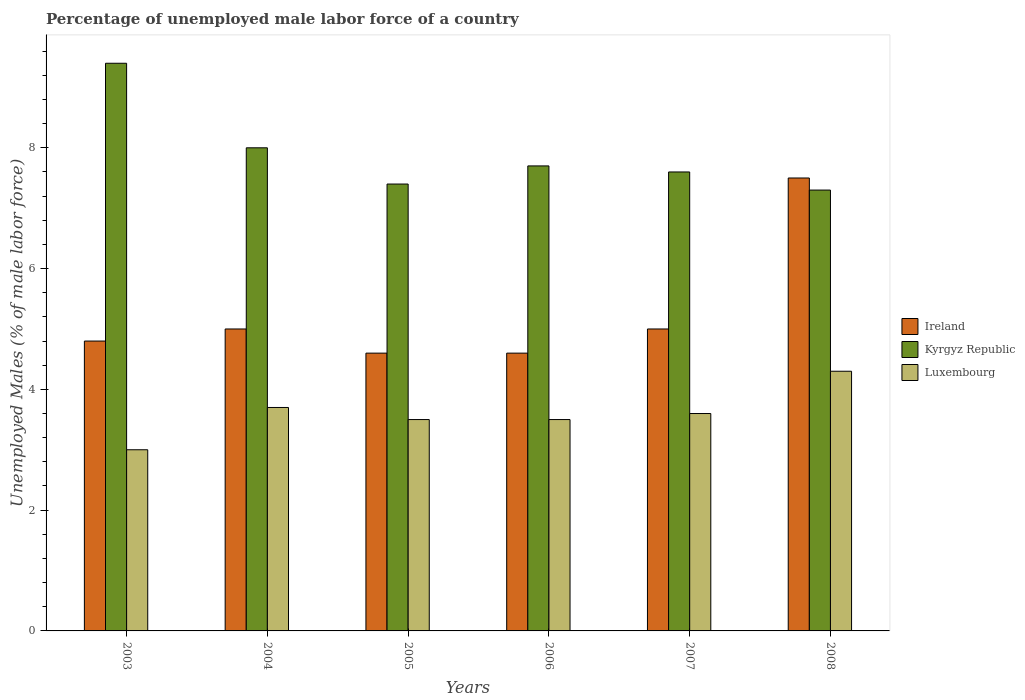How many groups of bars are there?
Your answer should be very brief. 6. In how many cases, is the number of bars for a given year not equal to the number of legend labels?
Make the answer very short. 0. What is the percentage of unemployed male labor force in Luxembourg in 2006?
Your answer should be very brief. 3.5. Across all years, what is the maximum percentage of unemployed male labor force in Kyrgyz Republic?
Your response must be concise. 9.4. Across all years, what is the minimum percentage of unemployed male labor force in Kyrgyz Republic?
Provide a short and direct response. 7.3. In which year was the percentage of unemployed male labor force in Luxembourg minimum?
Your response must be concise. 2003. What is the total percentage of unemployed male labor force in Luxembourg in the graph?
Your answer should be very brief. 21.6. What is the difference between the percentage of unemployed male labor force in Kyrgyz Republic in 2007 and that in 2008?
Offer a terse response. 0.3. What is the difference between the percentage of unemployed male labor force in Kyrgyz Republic in 2007 and the percentage of unemployed male labor force in Luxembourg in 2005?
Offer a terse response. 4.1. What is the average percentage of unemployed male labor force in Kyrgyz Republic per year?
Your answer should be very brief. 7.9. In the year 2005, what is the difference between the percentage of unemployed male labor force in Ireland and percentage of unemployed male labor force in Kyrgyz Republic?
Offer a terse response. -2.8. In how many years, is the percentage of unemployed male labor force in Kyrgyz Republic greater than 8.4 %?
Your response must be concise. 1. What is the ratio of the percentage of unemployed male labor force in Luxembourg in 2007 to that in 2008?
Your answer should be very brief. 0.84. Is the percentage of unemployed male labor force in Ireland in 2004 less than that in 2006?
Offer a very short reply. No. Is the difference between the percentage of unemployed male labor force in Ireland in 2004 and 2007 greater than the difference between the percentage of unemployed male labor force in Kyrgyz Republic in 2004 and 2007?
Your response must be concise. No. What is the difference between the highest and the lowest percentage of unemployed male labor force in Luxembourg?
Your answer should be compact. 1.3. In how many years, is the percentage of unemployed male labor force in Ireland greater than the average percentage of unemployed male labor force in Ireland taken over all years?
Ensure brevity in your answer.  1. What does the 1st bar from the left in 2006 represents?
Make the answer very short. Ireland. What does the 3rd bar from the right in 2006 represents?
Offer a very short reply. Ireland. How many bars are there?
Offer a terse response. 18. Are all the bars in the graph horizontal?
Offer a very short reply. No. What is the difference between two consecutive major ticks on the Y-axis?
Give a very brief answer. 2. Does the graph contain any zero values?
Your answer should be very brief. No. Where does the legend appear in the graph?
Give a very brief answer. Center right. How many legend labels are there?
Your answer should be compact. 3. What is the title of the graph?
Give a very brief answer. Percentage of unemployed male labor force of a country. What is the label or title of the X-axis?
Offer a terse response. Years. What is the label or title of the Y-axis?
Offer a terse response. Unemployed Males (% of male labor force). What is the Unemployed Males (% of male labor force) in Ireland in 2003?
Make the answer very short. 4.8. What is the Unemployed Males (% of male labor force) in Kyrgyz Republic in 2003?
Provide a succinct answer. 9.4. What is the Unemployed Males (% of male labor force) of Luxembourg in 2004?
Provide a succinct answer. 3.7. What is the Unemployed Males (% of male labor force) in Ireland in 2005?
Provide a short and direct response. 4.6. What is the Unemployed Males (% of male labor force) of Kyrgyz Republic in 2005?
Make the answer very short. 7.4. What is the Unemployed Males (% of male labor force) in Ireland in 2006?
Your answer should be compact. 4.6. What is the Unemployed Males (% of male labor force) of Kyrgyz Republic in 2006?
Offer a terse response. 7.7. What is the Unemployed Males (% of male labor force) of Kyrgyz Republic in 2007?
Make the answer very short. 7.6. What is the Unemployed Males (% of male labor force) in Luxembourg in 2007?
Offer a terse response. 3.6. What is the Unemployed Males (% of male labor force) in Kyrgyz Republic in 2008?
Keep it short and to the point. 7.3. What is the Unemployed Males (% of male labor force) of Luxembourg in 2008?
Ensure brevity in your answer.  4.3. Across all years, what is the maximum Unemployed Males (% of male labor force) in Kyrgyz Republic?
Offer a terse response. 9.4. Across all years, what is the maximum Unemployed Males (% of male labor force) in Luxembourg?
Make the answer very short. 4.3. Across all years, what is the minimum Unemployed Males (% of male labor force) of Ireland?
Provide a succinct answer. 4.6. Across all years, what is the minimum Unemployed Males (% of male labor force) of Kyrgyz Republic?
Provide a succinct answer. 7.3. Across all years, what is the minimum Unemployed Males (% of male labor force) in Luxembourg?
Offer a very short reply. 3. What is the total Unemployed Males (% of male labor force) in Ireland in the graph?
Offer a very short reply. 31.5. What is the total Unemployed Males (% of male labor force) of Kyrgyz Republic in the graph?
Provide a succinct answer. 47.4. What is the total Unemployed Males (% of male labor force) of Luxembourg in the graph?
Ensure brevity in your answer.  21.6. What is the difference between the Unemployed Males (% of male labor force) of Kyrgyz Republic in 2003 and that in 2004?
Provide a succinct answer. 1.4. What is the difference between the Unemployed Males (% of male labor force) in Kyrgyz Republic in 2003 and that in 2005?
Give a very brief answer. 2. What is the difference between the Unemployed Males (% of male labor force) of Luxembourg in 2003 and that in 2005?
Provide a short and direct response. -0.5. What is the difference between the Unemployed Males (% of male labor force) in Ireland in 2003 and that in 2006?
Ensure brevity in your answer.  0.2. What is the difference between the Unemployed Males (% of male labor force) of Luxembourg in 2003 and that in 2006?
Keep it short and to the point. -0.5. What is the difference between the Unemployed Males (% of male labor force) in Kyrgyz Republic in 2003 and that in 2007?
Your answer should be compact. 1.8. What is the difference between the Unemployed Males (% of male labor force) of Luxembourg in 2003 and that in 2007?
Keep it short and to the point. -0.6. What is the difference between the Unemployed Males (% of male labor force) in Ireland in 2003 and that in 2008?
Your answer should be very brief. -2.7. What is the difference between the Unemployed Males (% of male labor force) in Kyrgyz Republic in 2003 and that in 2008?
Offer a terse response. 2.1. What is the difference between the Unemployed Males (% of male labor force) in Ireland in 2004 and that in 2005?
Make the answer very short. 0.4. What is the difference between the Unemployed Males (% of male labor force) of Kyrgyz Republic in 2004 and that in 2005?
Give a very brief answer. 0.6. What is the difference between the Unemployed Males (% of male labor force) in Luxembourg in 2004 and that in 2005?
Your answer should be compact. 0.2. What is the difference between the Unemployed Males (% of male labor force) of Ireland in 2004 and that in 2006?
Provide a succinct answer. 0.4. What is the difference between the Unemployed Males (% of male labor force) of Kyrgyz Republic in 2004 and that in 2006?
Offer a terse response. 0.3. What is the difference between the Unemployed Males (% of male labor force) in Luxembourg in 2004 and that in 2006?
Your answer should be compact. 0.2. What is the difference between the Unemployed Males (% of male labor force) in Luxembourg in 2004 and that in 2007?
Offer a terse response. 0.1. What is the difference between the Unemployed Males (% of male labor force) of Ireland in 2004 and that in 2008?
Offer a terse response. -2.5. What is the difference between the Unemployed Males (% of male labor force) in Kyrgyz Republic in 2004 and that in 2008?
Offer a very short reply. 0.7. What is the difference between the Unemployed Males (% of male labor force) in Luxembourg in 2004 and that in 2008?
Give a very brief answer. -0.6. What is the difference between the Unemployed Males (% of male labor force) of Ireland in 2005 and that in 2006?
Your answer should be compact. 0. What is the difference between the Unemployed Males (% of male labor force) of Kyrgyz Republic in 2005 and that in 2007?
Ensure brevity in your answer.  -0.2. What is the difference between the Unemployed Males (% of male labor force) of Ireland in 2005 and that in 2008?
Keep it short and to the point. -2.9. What is the difference between the Unemployed Males (% of male labor force) of Kyrgyz Republic in 2005 and that in 2008?
Give a very brief answer. 0.1. What is the difference between the Unemployed Males (% of male labor force) of Ireland in 2006 and that in 2007?
Provide a succinct answer. -0.4. What is the difference between the Unemployed Males (% of male labor force) of Luxembourg in 2006 and that in 2007?
Provide a short and direct response. -0.1. What is the difference between the Unemployed Males (% of male labor force) in Luxembourg in 2006 and that in 2008?
Make the answer very short. -0.8. What is the difference between the Unemployed Males (% of male labor force) in Ireland in 2007 and that in 2008?
Offer a very short reply. -2.5. What is the difference between the Unemployed Males (% of male labor force) in Kyrgyz Republic in 2007 and that in 2008?
Make the answer very short. 0.3. What is the difference between the Unemployed Males (% of male labor force) in Ireland in 2003 and the Unemployed Males (% of male labor force) in Kyrgyz Republic in 2004?
Your answer should be very brief. -3.2. What is the difference between the Unemployed Males (% of male labor force) of Ireland in 2003 and the Unemployed Males (% of male labor force) of Kyrgyz Republic in 2007?
Ensure brevity in your answer.  -2.8. What is the difference between the Unemployed Males (% of male labor force) of Kyrgyz Republic in 2003 and the Unemployed Males (% of male labor force) of Luxembourg in 2007?
Offer a terse response. 5.8. What is the difference between the Unemployed Males (% of male labor force) of Ireland in 2003 and the Unemployed Males (% of male labor force) of Kyrgyz Republic in 2008?
Offer a very short reply. -2.5. What is the difference between the Unemployed Males (% of male labor force) in Ireland in 2003 and the Unemployed Males (% of male labor force) in Luxembourg in 2008?
Your answer should be compact. 0.5. What is the difference between the Unemployed Males (% of male labor force) of Kyrgyz Republic in 2004 and the Unemployed Males (% of male labor force) of Luxembourg in 2005?
Your answer should be compact. 4.5. What is the difference between the Unemployed Males (% of male labor force) of Ireland in 2004 and the Unemployed Males (% of male labor force) of Luxembourg in 2006?
Your answer should be very brief. 1.5. What is the difference between the Unemployed Males (% of male labor force) of Ireland in 2004 and the Unemployed Males (% of male labor force) of Kyrgyz Republic in 2007?
Your answer should be compact. -2.6. What is the difference between the Unemployed Males (% of male labor force) of Ireland in 2004 and the Unemployed Males (% of male labor force) of Luxembourg in 2007?
Offer a terse response. 1.4. What is the difference between the Unemployed Males (% of male labor force) of Kyrgyz Republic in 2004 and the Unemployed Males (% of male labor force) of Luxembourg in 2007?
Your response must be concise. 4.4. What is the difference between the Unemployed Males (% of male labor force) of Ireland in 2005 and the Unemployed Males (% of male labor force) of Kyrgyz Republic in 2006?
Keep it short and to the point. -3.1. What is the difference between the Unemployed Males (% of male labor force) of Kyrgyz Republic in 2005 and the Unemployed Males (% of male labor force) of Luxembourg in 2007?
Offer a terse response. 3.8. What is the difference between the Unemployed Males (% of male labor force) of Ireland in 2005 and the Unemployed Males (% of male labor force) of Kyrgyz Republic in 2008?
Provide a short and direct response. -2.7. What is the difference between the Unemployed Males (% of male labor force) of Ireland in 2006 and the Unemployed Males (% of male labor force) of Kyrgyz Republic in 2007?
Offer a very short reply. -3. What is the difference between the Unemployed Males (% of male labor force) of Ireland in 2006 and the Unemployed Males (% of male labor force) of Luxembourg in 2007?
Offer a terse response. 1. What is the difference between the Unemployed Males (% of male labor force) in Ireland in 2006 and the Unemployed Males (% of male labor force) in Luxembourg in 2008?
Give a very brief answer. 0.3. What is the difference between the Unemployed Males (% of male labor force) of Ireland in 2007 and the Unemployed Males (% of male labor force) of Kyrgyz Republic in 2008?
Keep it short and to the point. -2.3. What is the difference between the Unemployed Males (% of male labor force) in Ireland in 2007 and the Unemployed Males (% of male labor force) in Luxembourg in 2008?
Your answer should be very brief. 0.7. What is the difference between the Unemployed Males (% of male labor force) in Kyrgyz Republic in 2007 and the Unemployed Males (% of male labor force) in Luxembourg in 2008?
Give a very brief answer. 3.3. What is the average Unemployed Males (% of male labor force) in Ireland per year?
Your answer should be very brief. 5.25. What is the average Unemployed Males (% of male labor force) in Luxembourg per year?
Offer a very short reply. 3.6. In the year 2004, what is the difference between the Unemployed Males (% of male labor force) in Ireland and Unemployed Males (% of male labor force) in Kyrgyz Republic?
Ensure brevity in your answer.  -3. In the year 2004, what is the difference between the Unemployed Males (% of male labor force) in Ireland and Unemployed Males (% of male labor force) in Luxembourg?
Give a very brief answer. 1.3. In the year 2006, what is the difference between the Unemployed Males (% of male labor force) in Ireland and Unemployed Males (% of male labor force) in Kyrgyz Republic?
Make the answer very short. -3.1. In the year 2006, what is the difference between the Unemployed Males (% of male labor force) of Kyrgyz Republic and Unemployed Males (% of male labor force) of Luxembourg?
Provide a succinct answer. 4.2. In the year 2007, what is the difference between the Unemployed Males (% of male labor force) in Ireland and Unemployed Males (% of male labor force) in Kyrgyz Republic?
Ensure brevity in your answer.  -2.6. In the year 2007, what is the difference between the Unemployed Males (% of male labor force) in Ireland and Unemployed Males (% of male labor force) in Luxembourg?
Your answer should be compact. 1.4. In the year 2007, what is the difference between the Unemployed Males (% of male labor force) of Kyrgyz Republic and Unemployed Males (% of male labor force) of Luxembourg?
Your response must be concise. 4. In the year 2008, what is the difference between the Unemployed Males (% of male labor force) of Ireland and Unemployed Males (% of male labor force) of Kyrgyz Republic?
Your answer should be very brief. 0.2. In the year 2008, what is the difference between the Unemployed Males (% of male labor force) of Kyrgyz Republic and Unemployed Males (% of male labor force) of Luxembourg?
Provide a succinct answer. 3. What is the ratio of the Unemployed Males (% of male labor force) of Kyrgyz Republic in 2003 to that in 2004?
Offer a terse response. 1.18. What is the ratio of the Unemployed Males (% of male labor force) of Luxembourg in 2003 to that in 2004?
Your answer should be compact. 0.81. What is the ratio of the Unemployed Males (% of male labor force) of Ireland in 2003 to that in 2005?
Give a very brief answer. 1.04. What is the ratio of the Unemployed Males (% of male labor force) in Kyrgyz Republic in 2003 to that in 2005?
Make the answer very short. 1.27. What is the ratio of the Unemployed Males (% of male labor force) in Luxembourg in 2003 to that in 2005?
Provide a short and direct response. 0.86. What is the ratio of the Unemployed Males (% of male labor force) in Ireland in 2003 to that in 2006?
Provide a short and direct response. 1.04. What is the ratio of the Unemployed Males (% of male labor force) in Kyrgyz Republic in 2003 to that in 2006?
Provide a succinct answer. 1.22. What is the ratio of the Unemployed Males (% of male labor force) of Kyrgyz Republic in 2003 to that in 2007?
Provide a succinct answer. 1.24. What is the ratio of the Unemployed Males (% of male labor force) of Luxembourg in 2003 to that in 2007?
Make the answer very short. 0.83. What is the ratio of the Unemployed Males (% of male labor force) in Ireland in 2003 to that in 2008?
Give a very brief answer. 0.64. What is the ratio of the Unemployed Males (% of male labor force) of Kyrgyz Republic in 2003 to that in 2008?
Your response must be concise. 1.29. What is the ratio of the Unemployed Males (% of male labor force) of Luxembourg in 2003 to that in 2008?
Give a very brief answer. 0.7. What is the ratio of the Unemployed Males (% of male labor force) of Ireland in 2004 to that in 2005?
Your answer should be compact. 1.09. What is the ratio of the Unemployed Males (% of male labor force) in Kyrgyz Republic in 2004 to that in 2005?
Make the answer very short. 1.08. What is the ratio of the Unemployed Males (% of male labor force) in Luxembourg in 2004 to that in 2005?
Keep it short and to the point. 1.06. What is the ratio of the Unemployed Males (% of male labor force) of Ireland in 2004 to that in 2006?
Your answer should be compact. 1.09. What is the ratio of the Unemployed Males (% of male labor force) in Kyrgyz Republic in 2004 to that in 2006?
Provide a succinct answer. 1.04. What is the ratio of the Unemployed Males (% of male labor force) in Luxembourg in 2004 to that in 2006?
Provide a succinct answer. 1.06. What is the ratio of the Unemployed Males (% of male labor force) of Ireland in 2004 to that in 2007?
Provide a short and direct response. 1. What is the ratio of the Unemployed Males (% of male labor force) of Kyrgyz Republic in 2004 to that in 2007?
Keep it short and to the point. 1.05. What is the ratio of the Unemployed Males (% of male labor force) of Luxembourg in 2004 to that in 2007?
Make the answer very short. 1.03. What is the ratio of the Unemployed Males (% of male labor force) in Ireland in 2004 to that in 2008?
Give a very brief answer. 0.67. What is the ratio of the Unemployed Males (% of male labor force) in Kyrgyz Republic in 2004 to that in 2008?
Your response must be concise. 1.1. What is the ratio of the Unemployed Males (% of male labor force) of Luxembourg in 2004 to that in 2008?
Your answer should be compact. 0.86. What is the ratio of the Unemployed Males (% of male labor force) of Ireland in 2005 to that in 2006?
Your answer should be compact. 1. What is the ratio of the Unemployed Males (% of male labor force) of Kyrgyz Republic in 2005 to that in 2007?
Give a very brief answer. 0.97. What is the ratio of the Unemployed Males (% of male labor force) in Luxembourg in 2005 to that in 2007?
Your answer should be very brief. 0.97. What is the ratio of the Unemployed Males (% of male labor force) in Ireland in 2005 to that in 2008?
Offer a terse response. 0.61. What is the ratio of the Unemployed Males (% of male labor force) in Kyrgyz Republic in 2005 to that in 2008?
Your answer should be very brief. 1.01. What is the ratio of the Unemployed Males (% of male labor force) of Luxembourg in 2005 to that in 2008?
Keep it short and to the point. 0.81. What is the ratio of the Unemployed Males (% of male labor force) of Ireland in 2006 to that in 2007?
Provide a succinct answer. 0.92. What is the ratio of the Unemployed Males (% of male labor force) in Kyrgyz Republic in 2006 to that in 2007?
Offer a very short reply. 1.01. What is the ratio of the Unemployed Males (% of male labor force) of Luxembourg in 2006 to that in 2007?
Keep it short and to the point. 0.97. What is the ratio of the Unemployed Males (% of male labor force) in Ireland in 2006 to that in 2008?
Offer a terse response. 0.61. What is the ratio of the Unemployed Males (% of male labor force) of Kyrgyz Republic in 2006 to that in 2008?
Your answer should be very brief. 1.05. What is the ratio of the Unemployed Males (% of male labor force) in Luxembourg in 2006 to that in 2008?
Your answer should be very brief. 0.81. What is the ratio of the Unemployed Males (% of male labor force) of Kyrgyz Republic in 2007 to that in 2008?
Keep it short and to the point. 1.04. What is the ratio of the Unemployed Males (% of male labor force) in Luxembourg in 2007 to that in 2008?
Make the answer very short. 0.84. What is the difference between the highest and the second highest Unemployed Males (% of male labor force) of Ireland?
Offer a terse response. 2.5. What is the difference between the highest and the lowest Unemployed Males (% of male labor force) of Ireland?
Offer a very short reply. 2.9. What is the difference between the highest and the lowest Unemployed Males (% of male labor force) in Kyrgyz Republic?
Make the answer very short. 2.1. What is the difference between the highest and the lowest Unemployed Males (% of male labor force) of Luxembourg?
Offer a terse response. 1.3. 